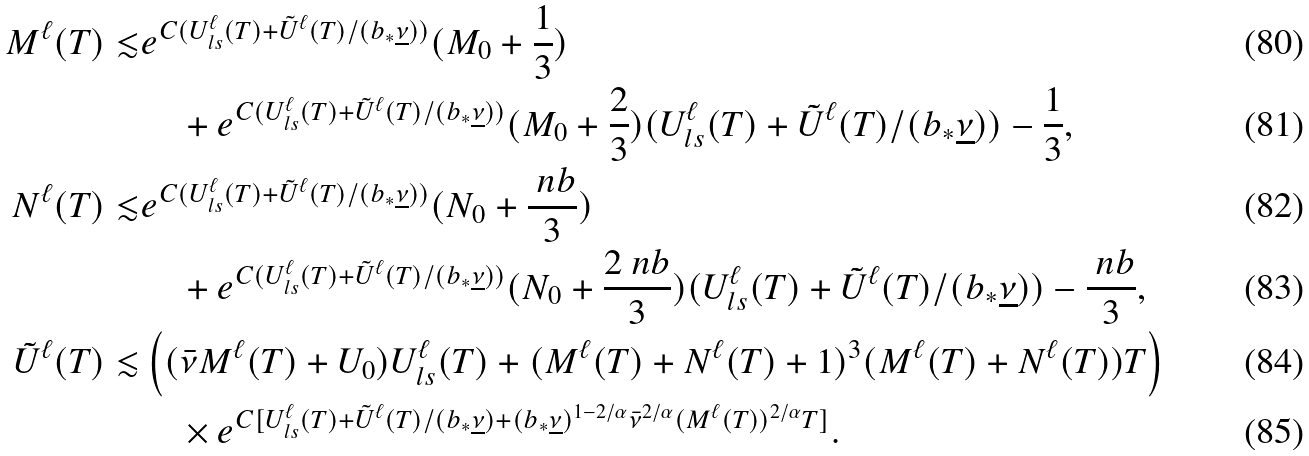<formula> <loc_0><loc_0><loc_500><loc_500>M ^ { \ell } ( T ) \lesssim & e ^ { C ( U _ { l s } ^ { \ell } ( T ) + \tilde { U } ^ { \ell } ( T ) / ( b _ { * } \underline { \nu } ) ) } ( M _ { 0 } + \frac { 1 } { 3 } ) \\ & \quad + e ^ { C ( U _ { l s } ^ { \ell } ( T ) + \tilde { U } ^ { \ell } ( T ) / ( b _ { * } \underline { \nu } ) ) } ( M _ { 0 } + \frac { 2 } { 3 } ) ( U _ { l s } ^ { \ell } ( T ) + \tilde { U } ^ { \ell } ( T ) / ( b _ { * } \underline { \nu } ) ) - \frac { 1 } { 3 } , \\ N ^ { \ell } ( T ) \lesssim & e ^ { C ( U _ { l s } ^ { \ell } ( T ) + \tilde { U } ^ { \ell } ( T ) / ( b _ { * } \underline { \nu } ) ) } ( N _ { 0 } + \frac { \ n b } { 3 } ) \\ & \quad + e ^ { C ( U _ { l s } ^ { \ell } ( T ) + \tilde { U } ^ { \ell } ( T ) / ( b _ { * } \underline { \nu } ) ) } ( N _ { 0 } + \frac { 2 \ n b } { 3 } ) ( U _ { l s } ^ { \ell } ( T ) + \tilde { U } ^ { \ell } ( T ) / ( b _ { * } \underline { \nu } ) ) - \frac { \ n b } { 3 } , \\ \tilde { U } ^ { \ell } ( T ) \lesssim & \left ( ( \bar { \nu } M ^ { \ell } ( T ) + U _ { 0 } ) U _ { l s } ^ { \ell } ( T ) + ( M ^ { \ell } ( T ) + N ^ { \ell } ( T ) + 1 ) ^ { 3 } ( M ^ { \ell } ( T ) + N ^ { \ell } ( T ) ) T \right ) \\ & \quad \times e ^ { C [ U _ { l s } ^ { \ell } ( T ) + \tilde { U } ^ { \ell } ( T ) / ( b _ { * } \underline { \nu } ) + ( b _ { * } \underline { \nu } ) ^ { 1 - 2 / \alpha } \bar { \nu } ^ { 2 / \alpha } ( M ^ { \ell } ( T ) ) ^ { 2 / \alpha } T ] } .</formula> 